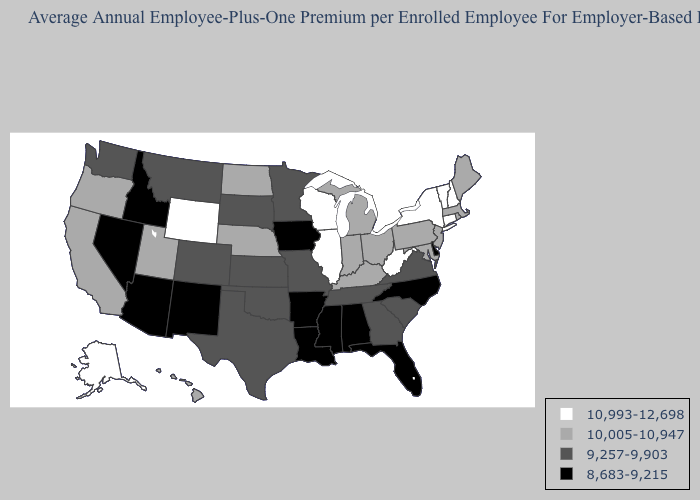What is the value of Indiana?
Short answer required. 10,005-10,947. Among the states that border New York , does Connecticut have the highest value?
Write a very short answer. Yes. What is the highest value in the Northeast ?
Concise answer only. 10,993-12,698. What is the lowest value in the USA?
Be succinct. 8,683-9,215. Name the states that have a value in the range 8,683-9,215?
Answer briefly. Alabama, Arizona, Arkansas, Delaware, Florida, Idaho, Iowa, Louisiana, Mississippi, Nevada, New Mexico, North Carolina. What is the lowest value in the Northeast?
Keep it brief. 10,005-10,947. Name the states that have a value in the range 10,005-10,947?
Quick response, please. California, Hawaii, Indiana, Kentucky, Maine, Maryland, Massachusetts, Michigan, Nebraska, New Jersey, North Dakota, Ohio, Oregon, Pennsylvania, Rhode Island, Utah. How many symbols are there in the legend?
Keep it brief. 4. Is the legend a continuous bar?
Give a very brief answer. No. Is the legend a continuous bar?
Be succinct. No. What is the value of Mississippi?
Write a very short answer. 8,683-9,215. Name the states that have a value in the range 10,993-12,698?
Quick response, please. Alaska, Connecticut, Illinois, New Hampshire, New York, Vermont, West Virginia, Wisconsin, Wyoming. Does the first symbol in the legend represent the smallest category?
Write a very short answer. No. What is the value of Idaho?
Write a very short answer. 8,683-9,215. 